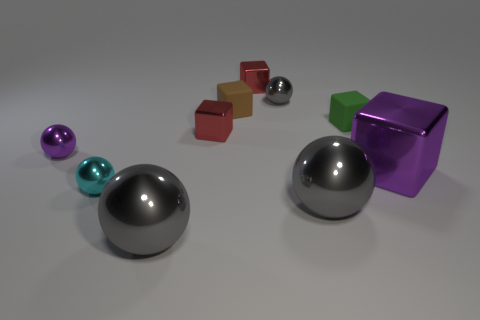How many gray balls must be subtracted to get 1 gray balls? 2 Subtract all blue cylinders. How many gray balls are left? 3 Subtract all large metallic cubes. How many cubes are left? 4 Subtract all purple spheres. How many spheres are left? 4 Subtract all purple blocks. Subtract all gray balls. How many blocks are left? 4 Add 7 tiny brown cylinders. How many tiny brown cylinders exist? 7 Subtract 0 cyan blocks. How many objects are left? 10 Subtract all blocks. Subtract all red things. How many objects are left? 3 Add 4 tiny gray metallic spheres. How many tiny gray metallic spheres are left? 5 